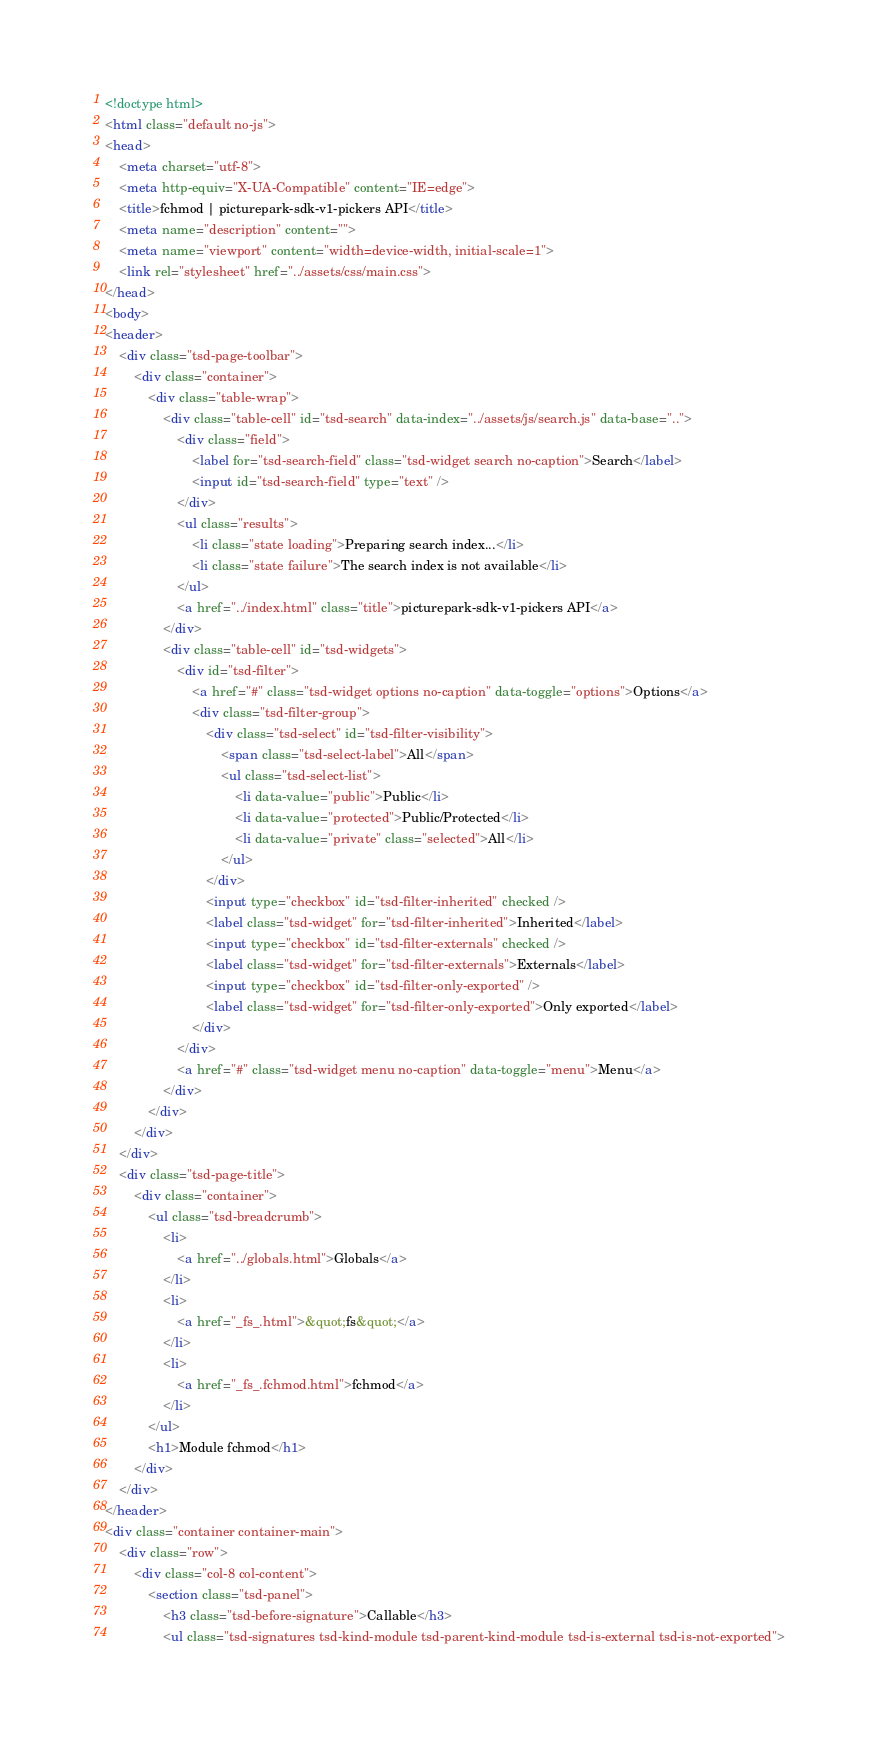<code> <loc_0><loc_0><loc_500><loc_500><_HTML_><!doctype html>
<html class="default no-js">
<head>
	<meta charset="utf-8">
	<meta http-equiv="X-UA-Compatible" content="IE=edge">
	<title>fchmod | picturepark-sdk-v1-pickers API</title>
	<meta name="description" content="">
	<meta name="viewport" content="width=device-width, initial-scale=1">
	<link rel="stylesheet" href="../assets/css/main.css">
</head>
<body>
<header>
	<div class="tsd-page-toolbar">
		<div class="container">
			<div class="table-wrap">
				<div class="table-cell" id="tsd-search" data-index="../assets/js/search.js" data-base="..">
					<div class="field">
						<label for="tsd-search-field" class="tsd-widget search no-caption">Search</label>
						<input id="tsd-search-field" type="text" />
					</div>
					<ul class="results">
						<li class="state loading">Preparing search index...</li>
						<li class="state failure">The search index is not available</li>
					</ul>
					<a href="../index.html" class="title">picturepark-sdk-v1-pickers API</a>
				</div>
				<div class="table-cell" id="tsd-widgets">
					<div id="tsd-filter">
						<a href="#" class="tsd-widget options no-caption" data-toggle="options">Options</a>
						<div class="tsd-filter-group">
							<div class="tsd-select" id="tsd-filter-visibility">
								<span class="tsd-select-label">All</span>
								<ul class="tsd-select-list">
									<li data-value="public">Public</li>
									<li data-value="protected">Public/Protected</li>
									<li data-value="private" class="selected">All</li>
								</ul>
							</div>
							<input type="checkbox" id="tsd-filter-inherited" checked />
							<label class="tsd-widget" for="tsd-filter-inherited">Inherited</label>
							<input type="checkbox" id="tsd-filter-externals" checked />
							<label class="tsd-widget" for="tsd-filter-externals">Externals</label>
							<input type="checkbox" id="tsd-filter-only-exported" />
							<label class="tsd-widget" for="tsd-filter-only-exported">Only exported</label>
						</div>
					</div>
					<a href="#" class="tsd-widget menu no-caption" data-toggle="menu">Menu</a>
				</div>
			</div>
		</div>
	</div>
	<div class="tsd-page-title">
		<div class="container">
			<ul class="tsd-breadcrumb">
				<li>
					<a href="../globals.html">Globals</a>
				</li>
				<li>
					<a href="_fs_.html">&quot;fs&quot;</a>
				</li>
				<li>
					<a href="_fs_.fchmod.html">fchmod</a>
				</li>
			</ul>
			<h1>Module fchmod</h1>
		</div>
	</div>
</header>
<div class="container container-main">
	<div class="row">
		<div class="col-8 col-content">
			<section class="tsd-panel">
				<h3 class="tsd-before-signature">Callable</h3>
				<ul class="tsd-signatures tsd-kind-module tsd-parent-kind-module tsd-is-external tsd-is-not-exported"></code> 